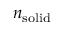Convert formula to latex. <formula><loc_0><loc_0><loc_500><loc_500>n _ { s o l i d }</formula> 